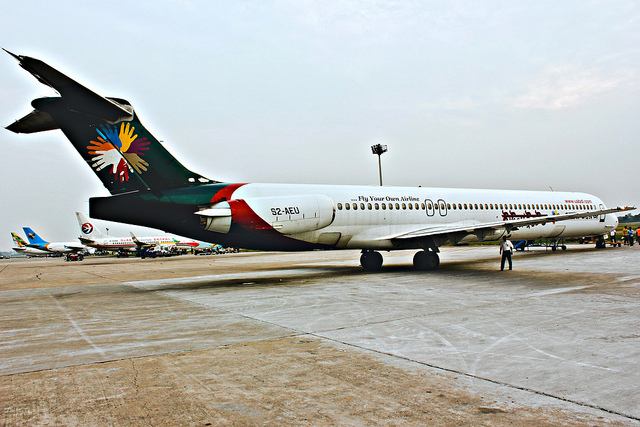<image>How owns this plane? I don't know who owns this plane. It could be owned by an airline company or a specific country like India, Mexico, or Canada. How owns this plane? I don't know who owns this plane. It could be owned by an airline company or a commercial airline. 